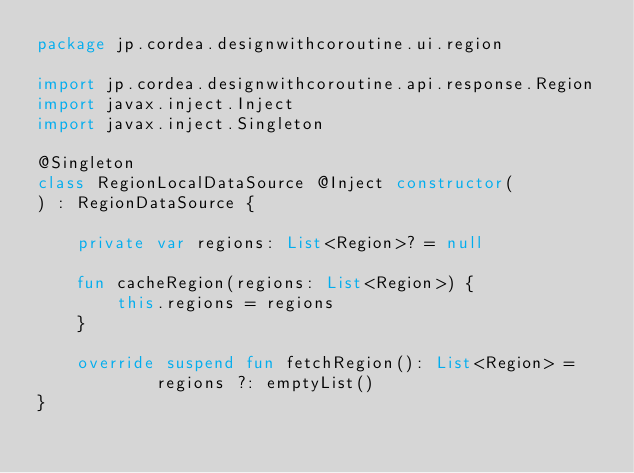<code> <loc_0><loc_0><loc_500><loc_500><_Kotlin_>package jp.cordea.designwithcoroutine.ui.region

import jp.cordea.designwithcoroutine.api.response.Region
import javax.inject.Inject
import javax.inject.Singleton

@Singleton
class RegionLocalDataSource @Inject constructor(
) : RegionDataSource {

    private var regions: List<Region>? = null

    fun cacheRegion(regions: List<Region>) {
        this.regions = regions
    }

    override suspend fun fetchRegion(): List<Region> =
            regions ?: emptyList()
}
</code> 